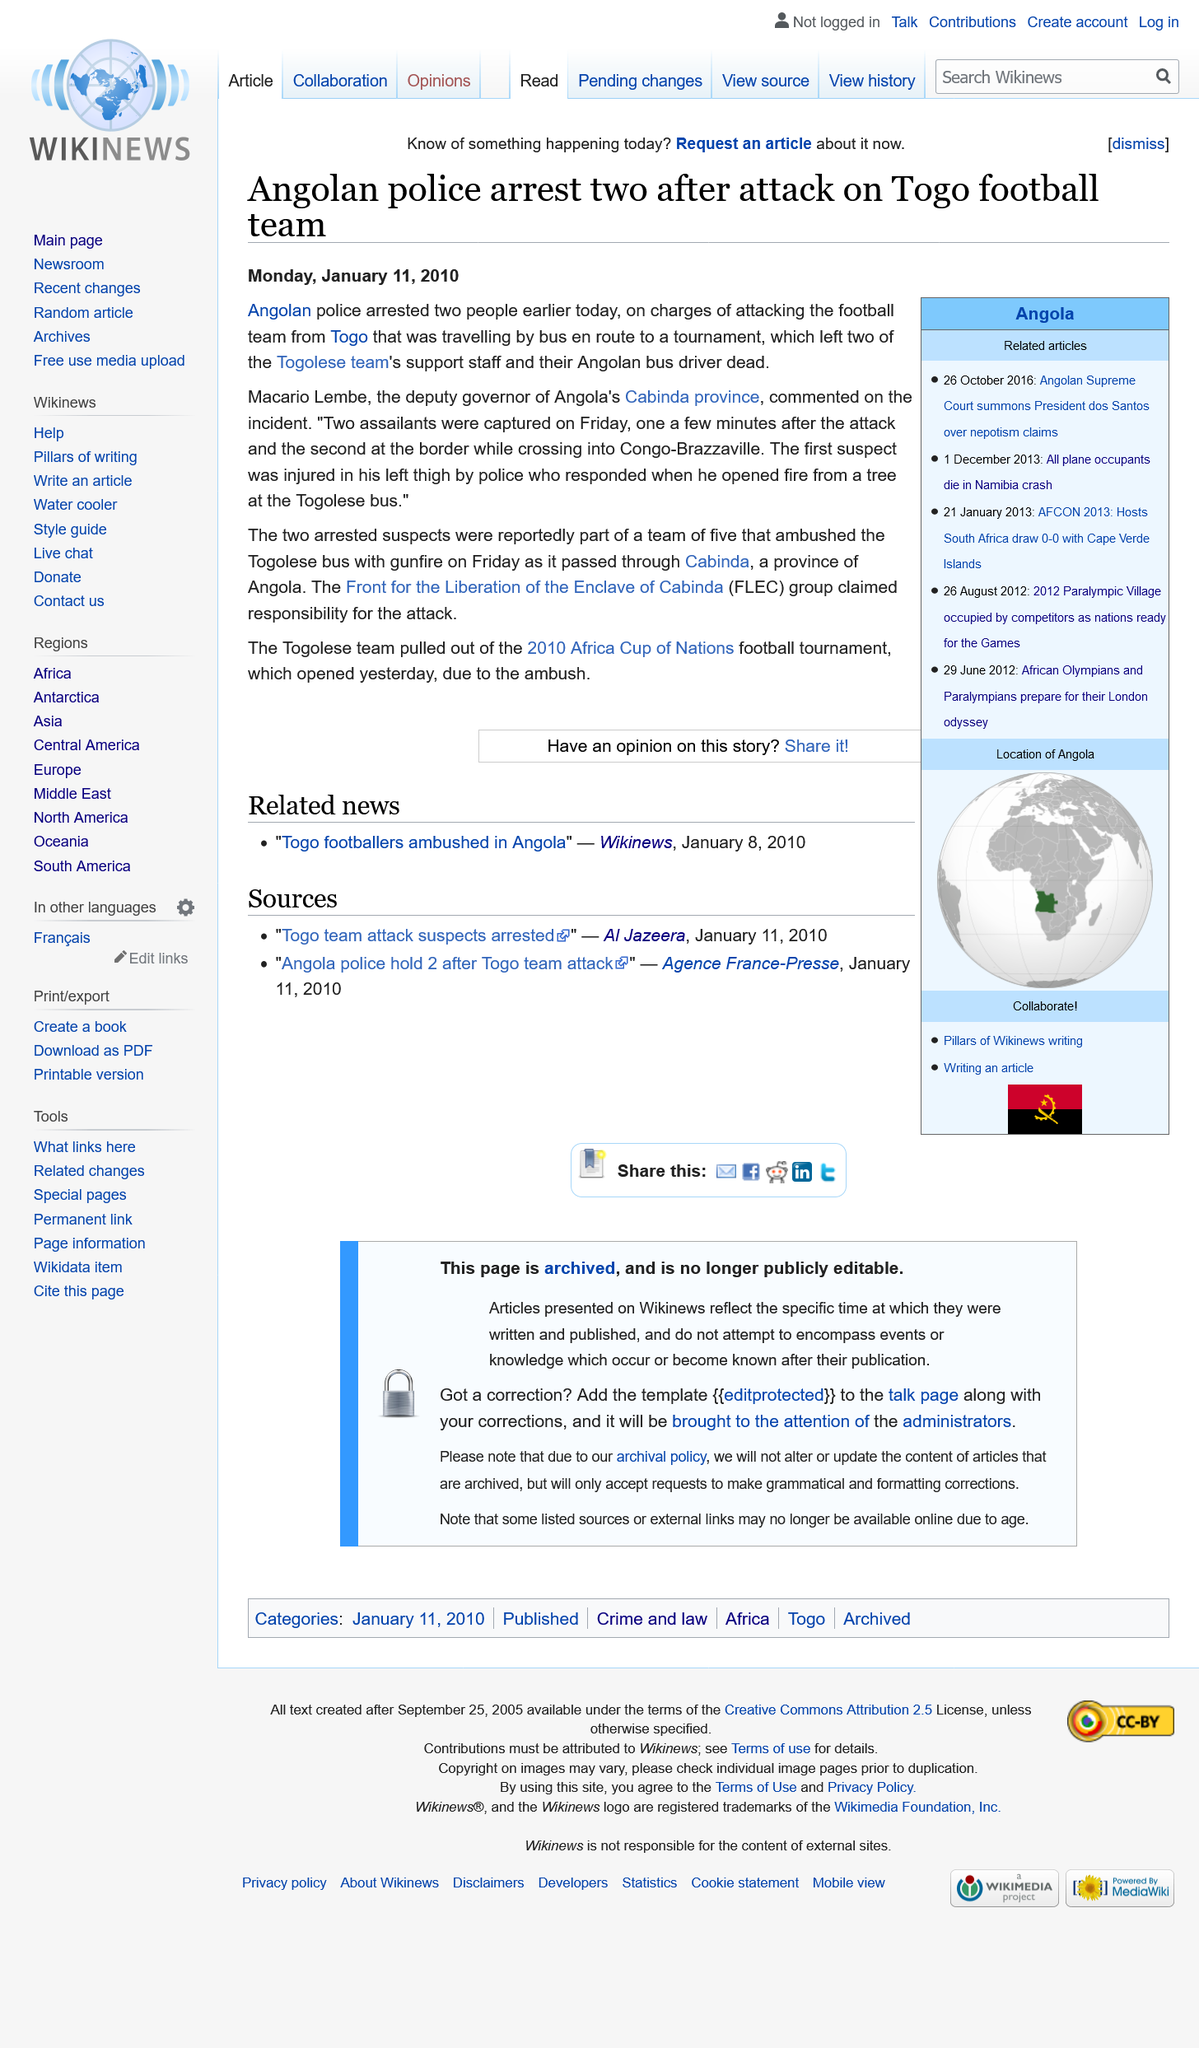Indicate a few pertinent items in this graphic. The Front for the Liberation of the Enclave of Cabinda confirms that one of its members was injured during the Angolan police response to the attack on the bus. The suspect sustained a gunshot wound to his left thigh. After the Togolese football team was attacked and their bus set on fire, they made the decision to withdraw from the 2010 Africa Cup of Nations tournament. The bus driver and two members of the Togolese team's support staff did not survive the Friday attack on their bus, in which they were killed. 